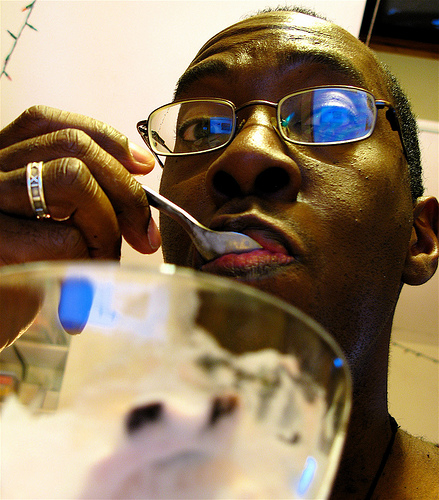<image>
Can you confirm if the ring is on the boy? Yes. Looking at the image, I can see the ring is positioned on top of the boy, with the boy providing support. Is there a spoon in the bowl? No. The spoon is not contained within the bowl. These objects have a different spatial relationship. 